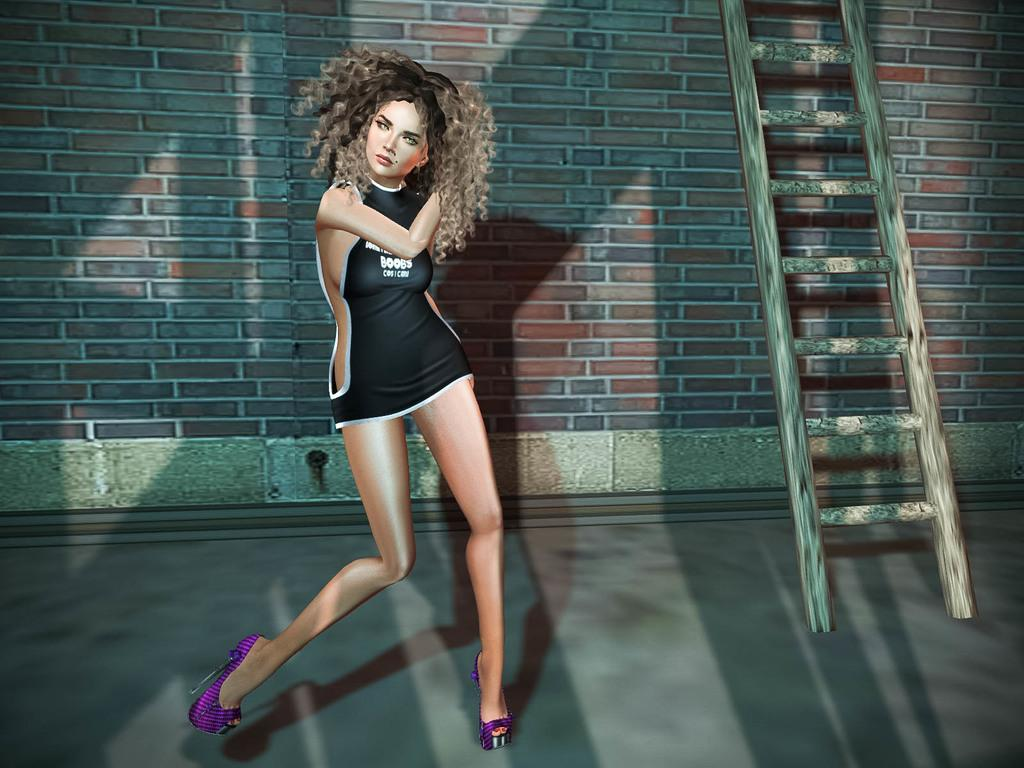What is the main subject of the image? There is a woman standing in the image. What object can be seen in the image besides the woman? There is a ladder in the image. What type of structure is visible in the image? There is a wall in the image. What type of tramp is visible in the image? There is no tramp present in the image; it features a woman, a ladder, and a wall. What is the end result of the rule in the image? There is no rule mentioned in the image, so it's not possible to determine an end result. 